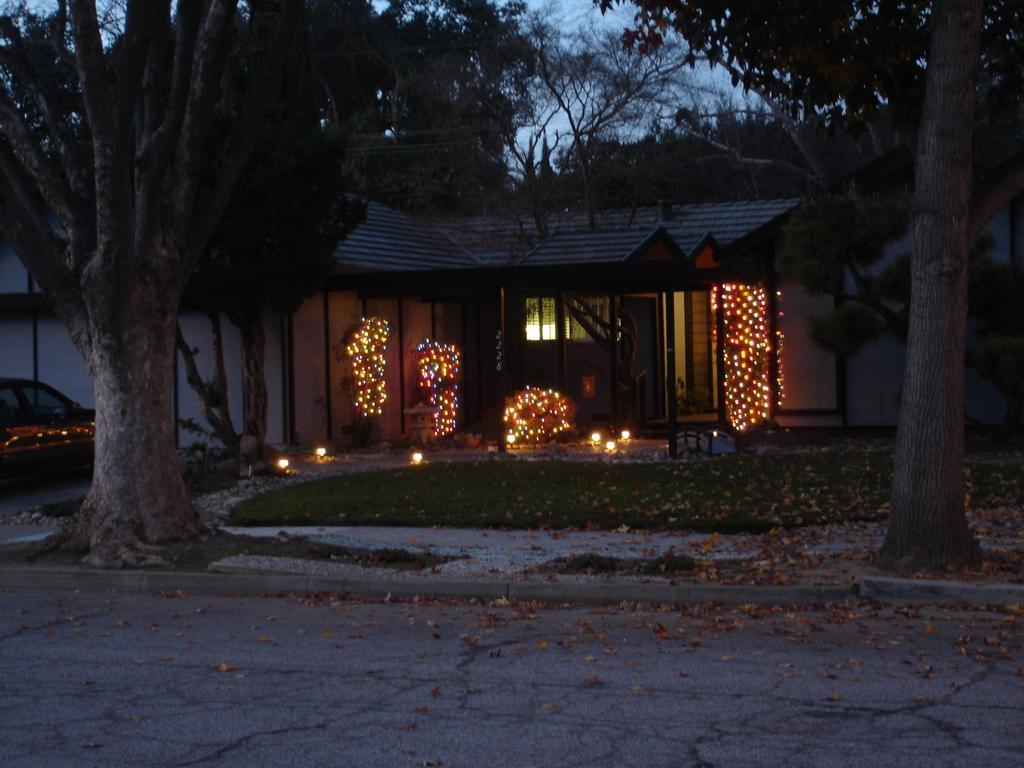Could you give a brief overview of what you see in this image? In this image we can see the vehicle and lights in front of the house and there are trees, grass, leaves, road and the sky. 